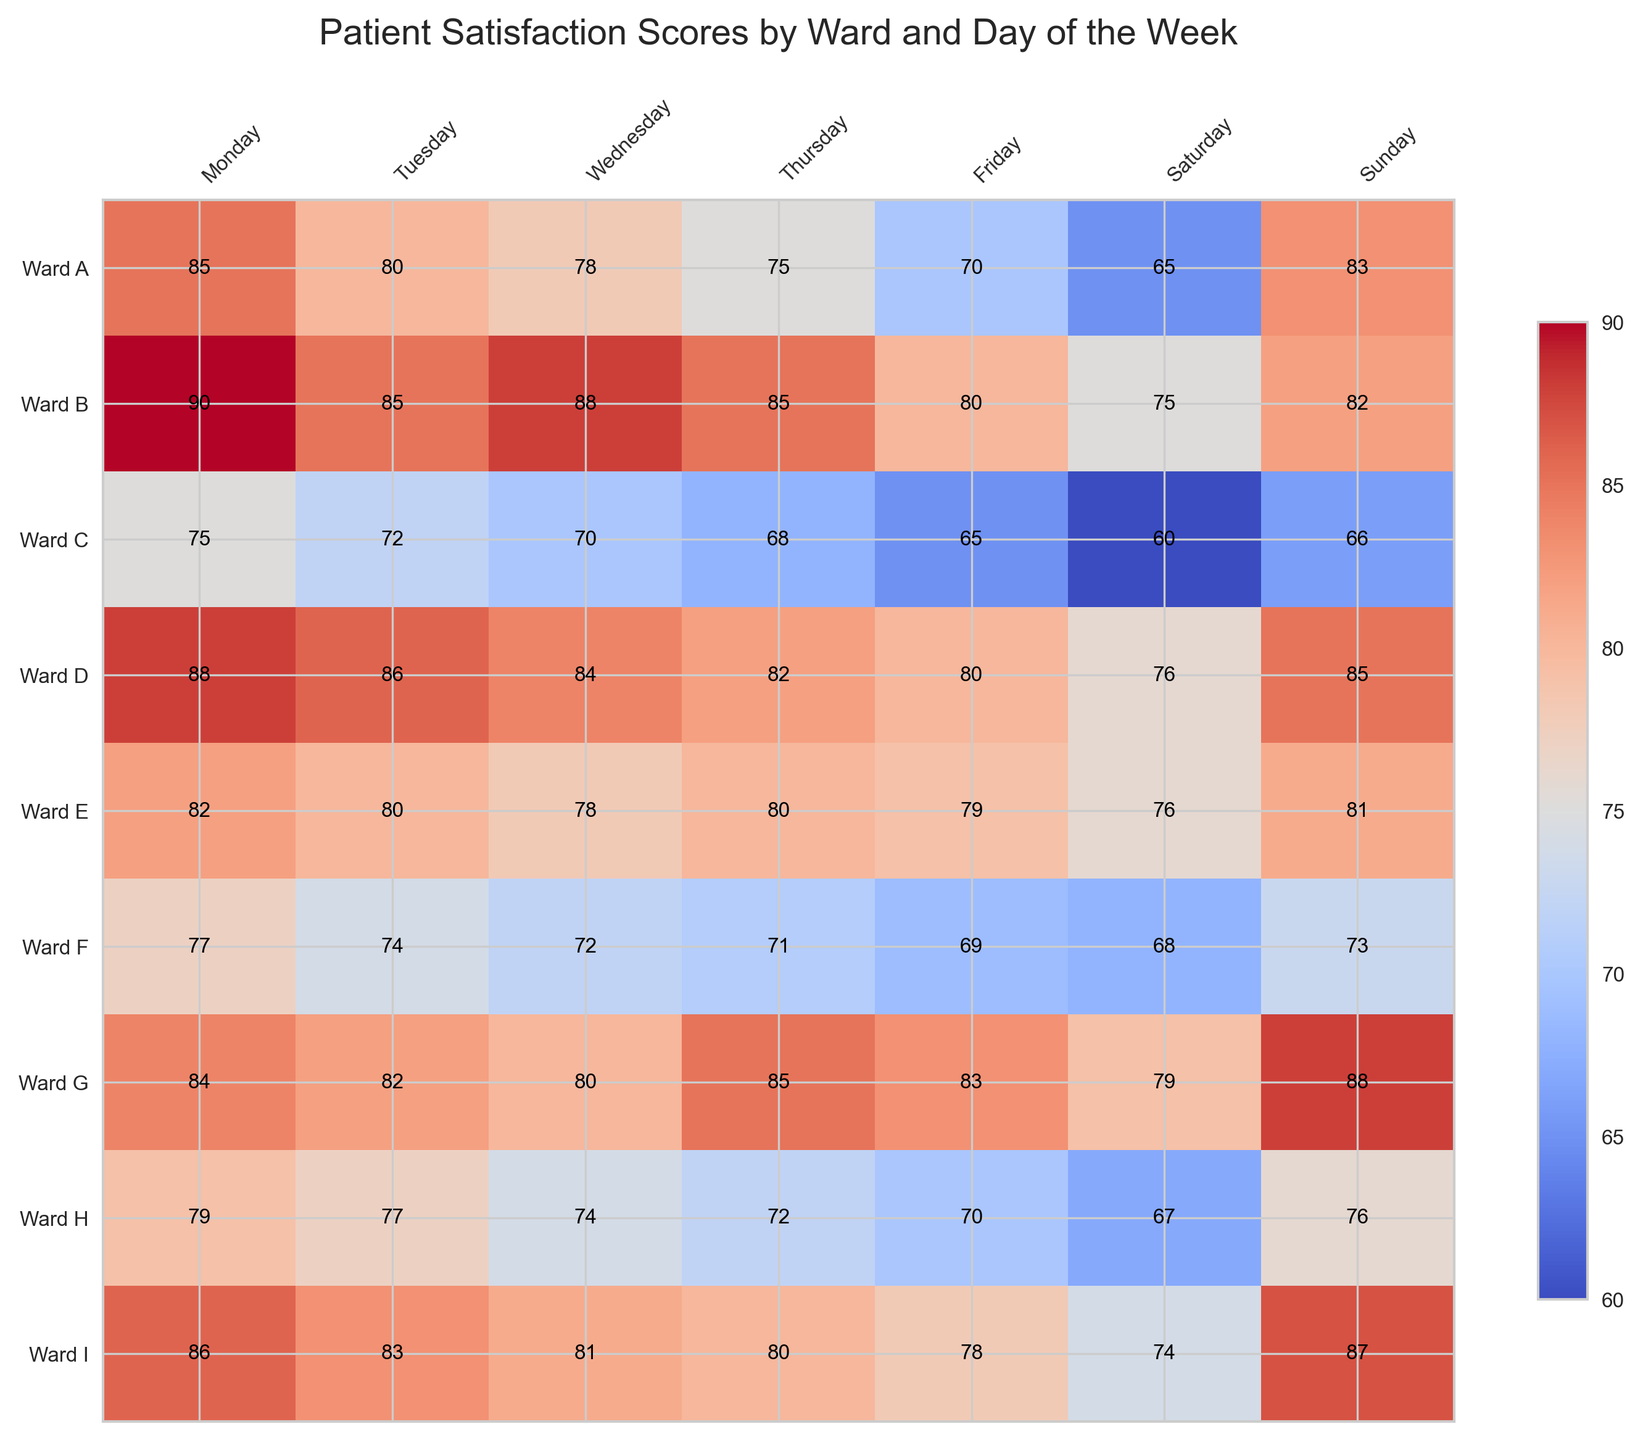What day has the highest patient satisfaction score for Ward G? To find the answer, locate Ward G in the heatmap and identify the highest value across the days of the week. For Ward G, the highest score is 88 on Sunday.
Answer: Sunday Which ward has the lowest patient satisfaction score on Wednesday? Compare the scores for all wards on Wednesday, and find the lowest one. The scores on Wednesday for the wards are Ward A: 78, Ward B: 88, Ward C: 70, Ward D: 84, Ward E: 78, Ward F: 72, Ward G: 80, Ward H: 74, Ward I: 81. The lowest score is 70 in Ward C.
Answer: Ward C What is the average patient satisfaction score for Ward B over the entire week? Sum the scores for Ward B and divide by the number of days (7). The scores are 90, 85, 88, 85, 80, 75, 82. The sum is 585. Dividing 585 by 7 gives an average of 83.57.
Answer: 83.57 